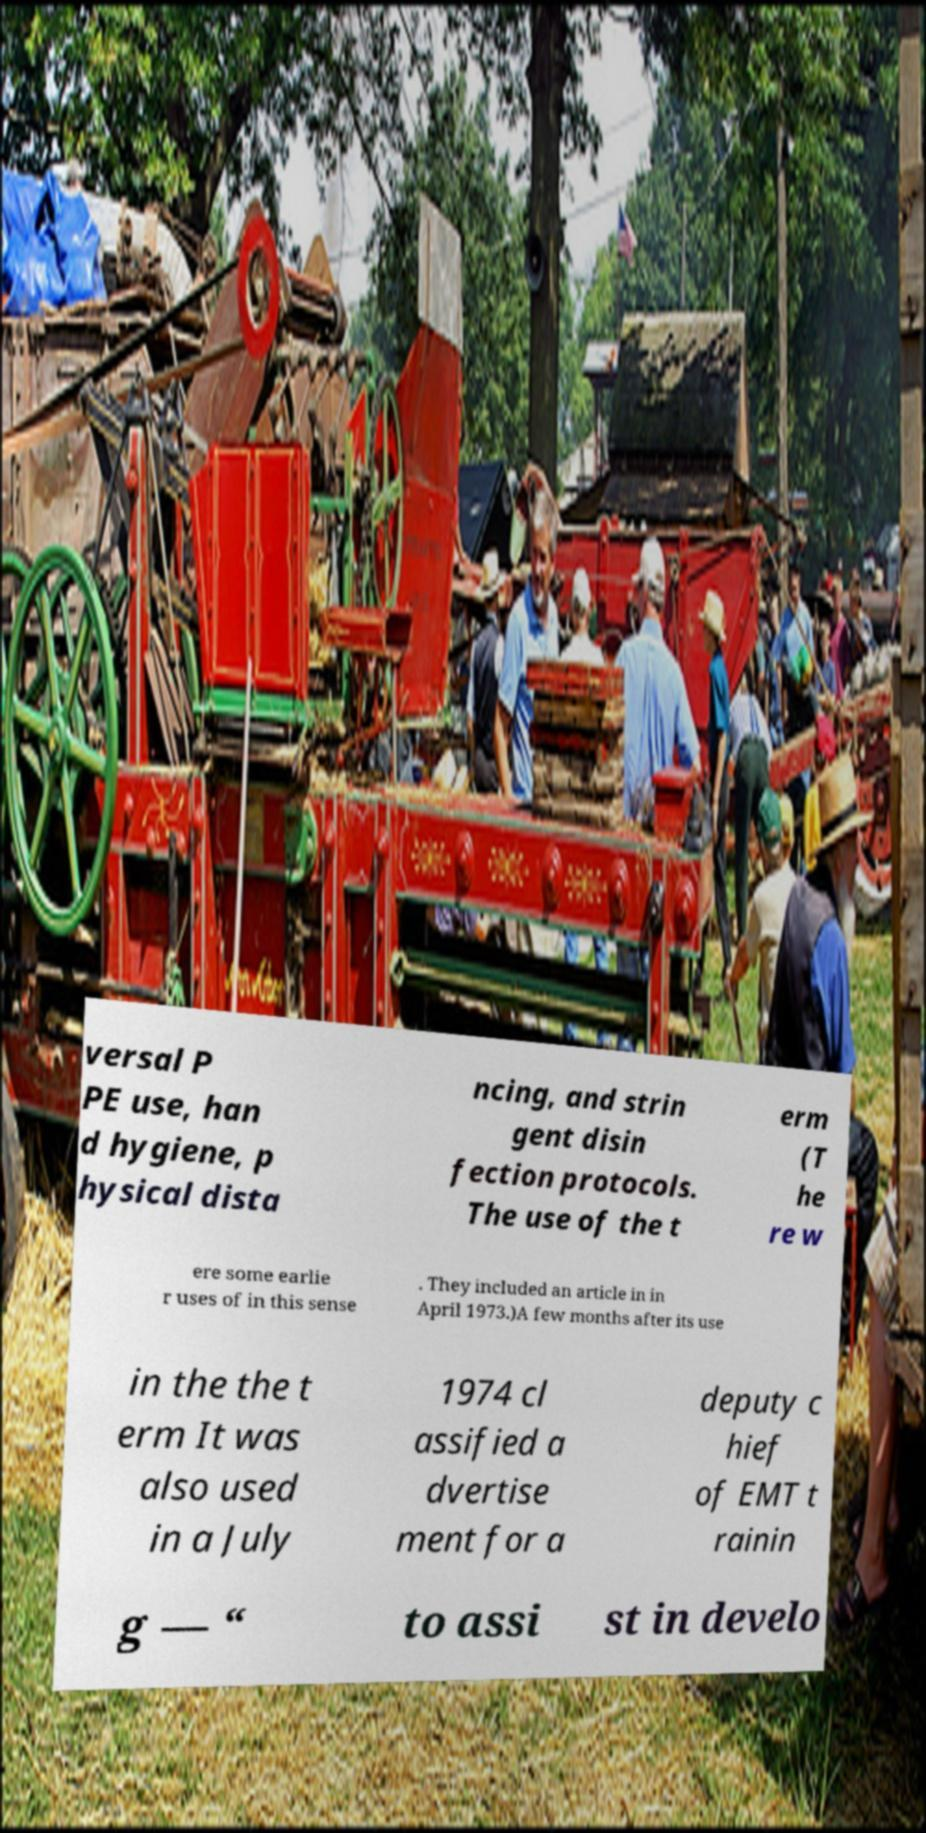Please read and relay the text visible in this image. What does it say? versal P PE use, han d hygiene, p hysical dista ncing, and strin gent disin fection protocols. The use of the t erm (T he re w ere some earlie r uses of in this sense . They included an article in in April 1973.)A few months after its use in the the t erm It was also used in a July 1974 cl assified a dvertise ment for a deputy c hief of EMT t rainin g — “ to assi st in develo 